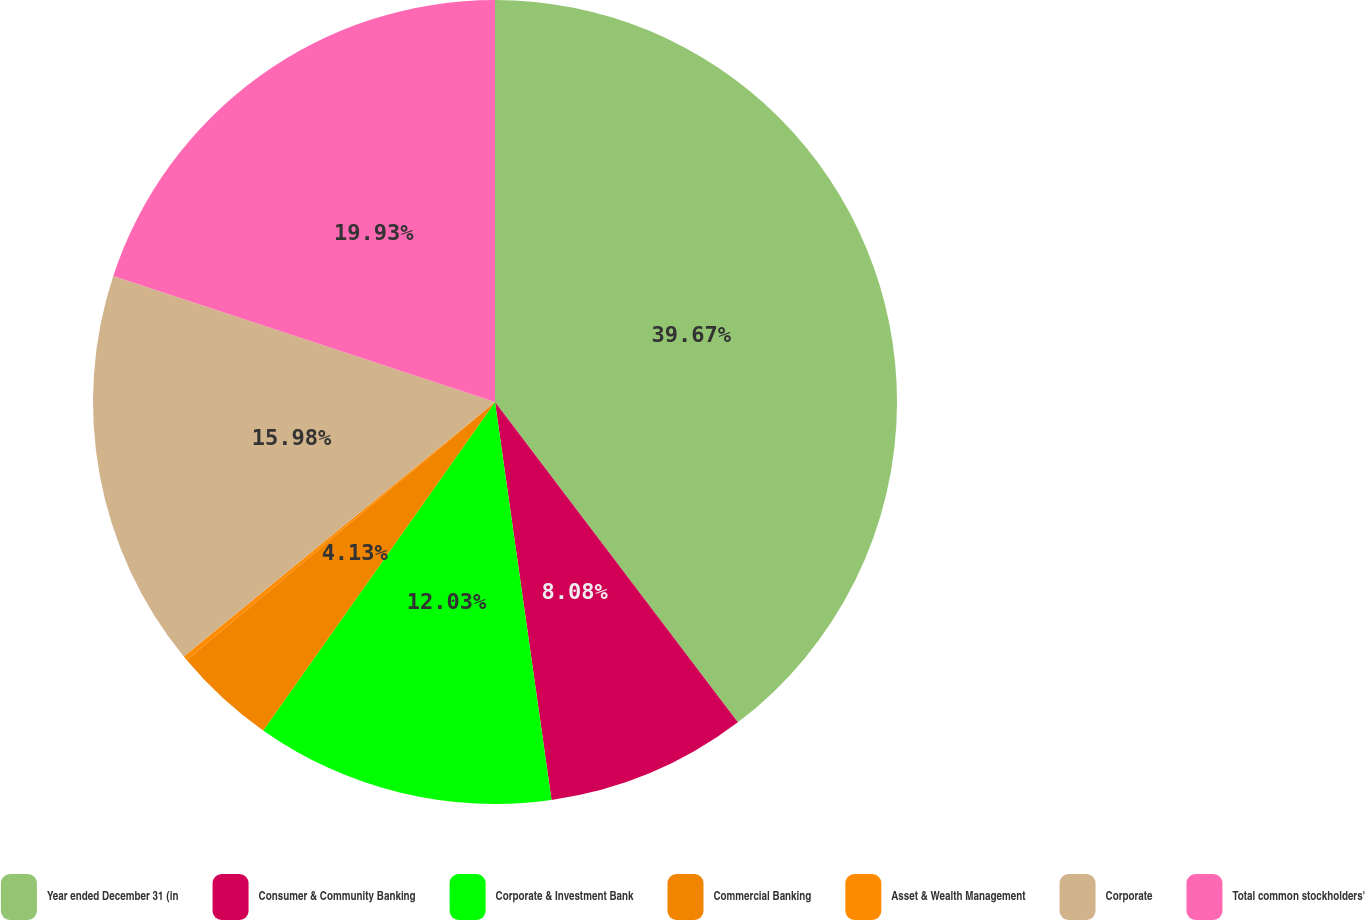Convert chart. <chart><loc_0><loc_0><loc_500><loc_500><pie_chart><fcel>Year ended December 31 (in<fcel>Consumer & Community Banking<fcel>Corporate & Investment Bank<fcel>Commercial Banking<fcel>Asset & Wealth Management<fcel>Corporate<fcel>Total common stockholders'<nl><fcel>39.68%<fcel>8.08%<fcel>12.03%<fcel>4.13%<fcel>0.18%<fcel>15.98%<fcel>19.93%<nl></chart> 